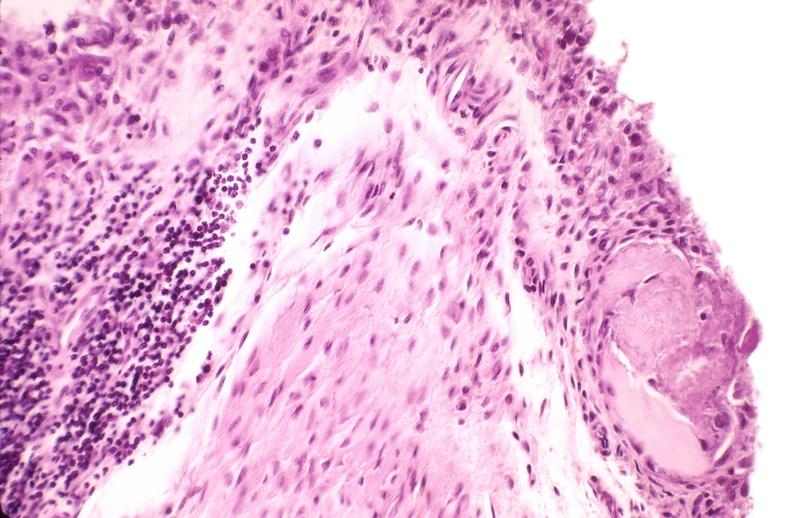what is present?
Answer the question using a single word or phrase. Joints 